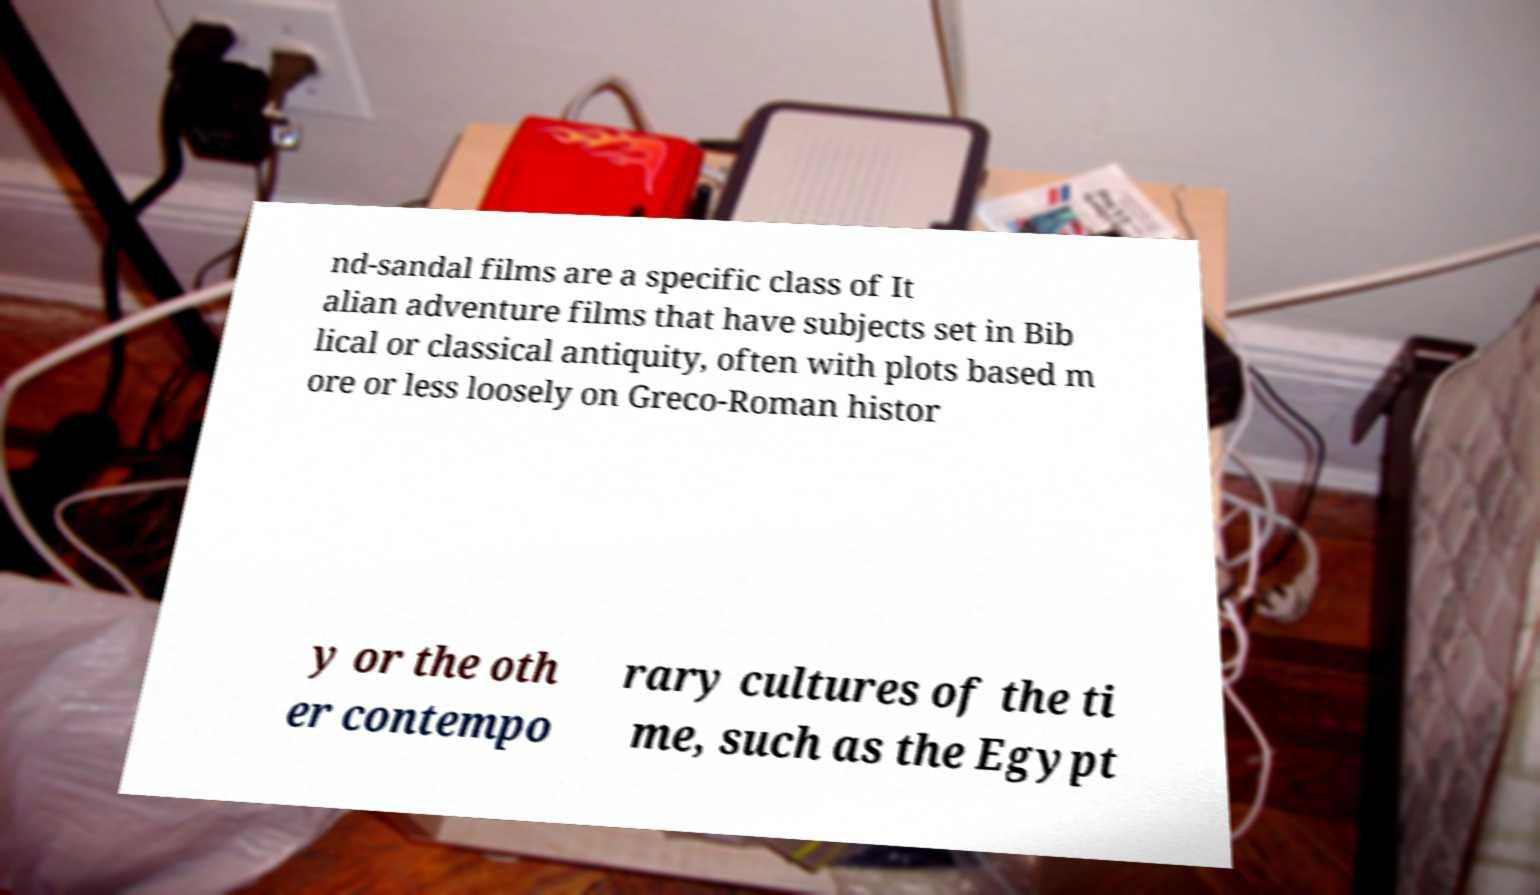Please read and relay the text visible in this image. What does it say? nd-sandal films are a specific class of It alian adventure films that have subjects set in Bib lical or classical antiquity, often with plots based m ore or less loosely on Greco-Roman histor y or the oth er contempo rary cultures of the ti me, such as the Egypt 